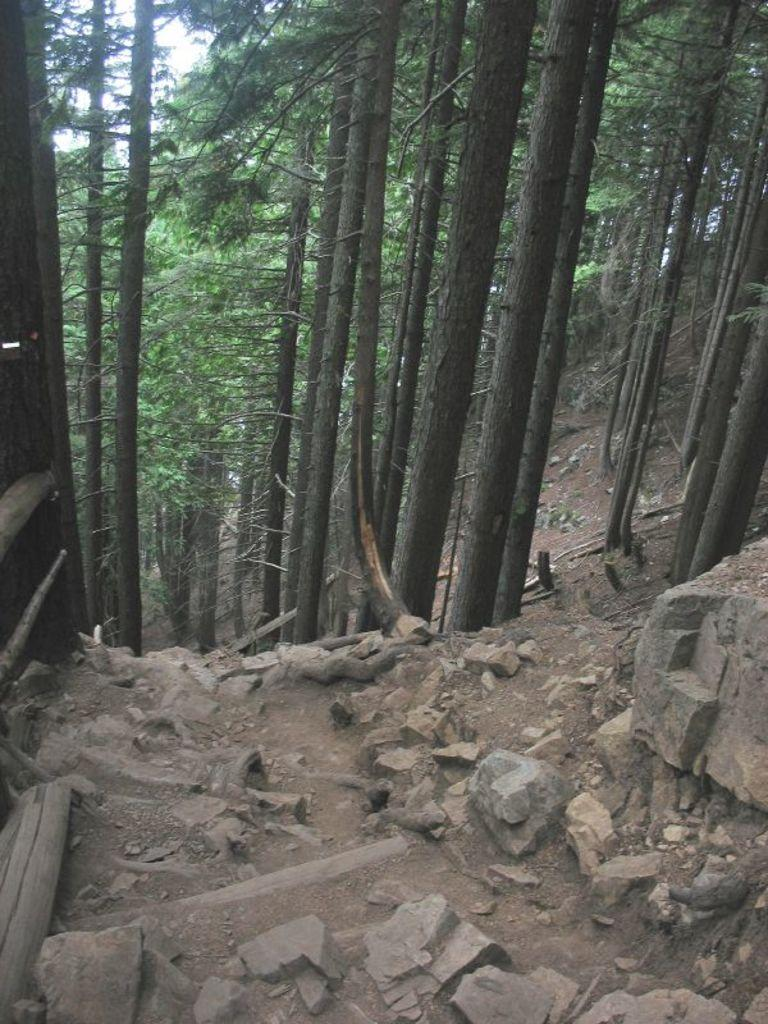What is at the bottom of the image? There is sand at the bottom of the image. What other natural elements can be seen in the image? There are rocks in the image. What man-made objects are present in the image? There are wooden sticks and a wooden board in the image. What can be seen in the background of the image? There is a group of trees in the background of the image. What type of crime is being committed in the image? There is no indication of any crime being committed in the image. What pet can be seen playing with the wooden sticks in the image? There is no pet present in the image; it only features sand, rocks, wooden sticks, a wooden board, and a group of trees. 